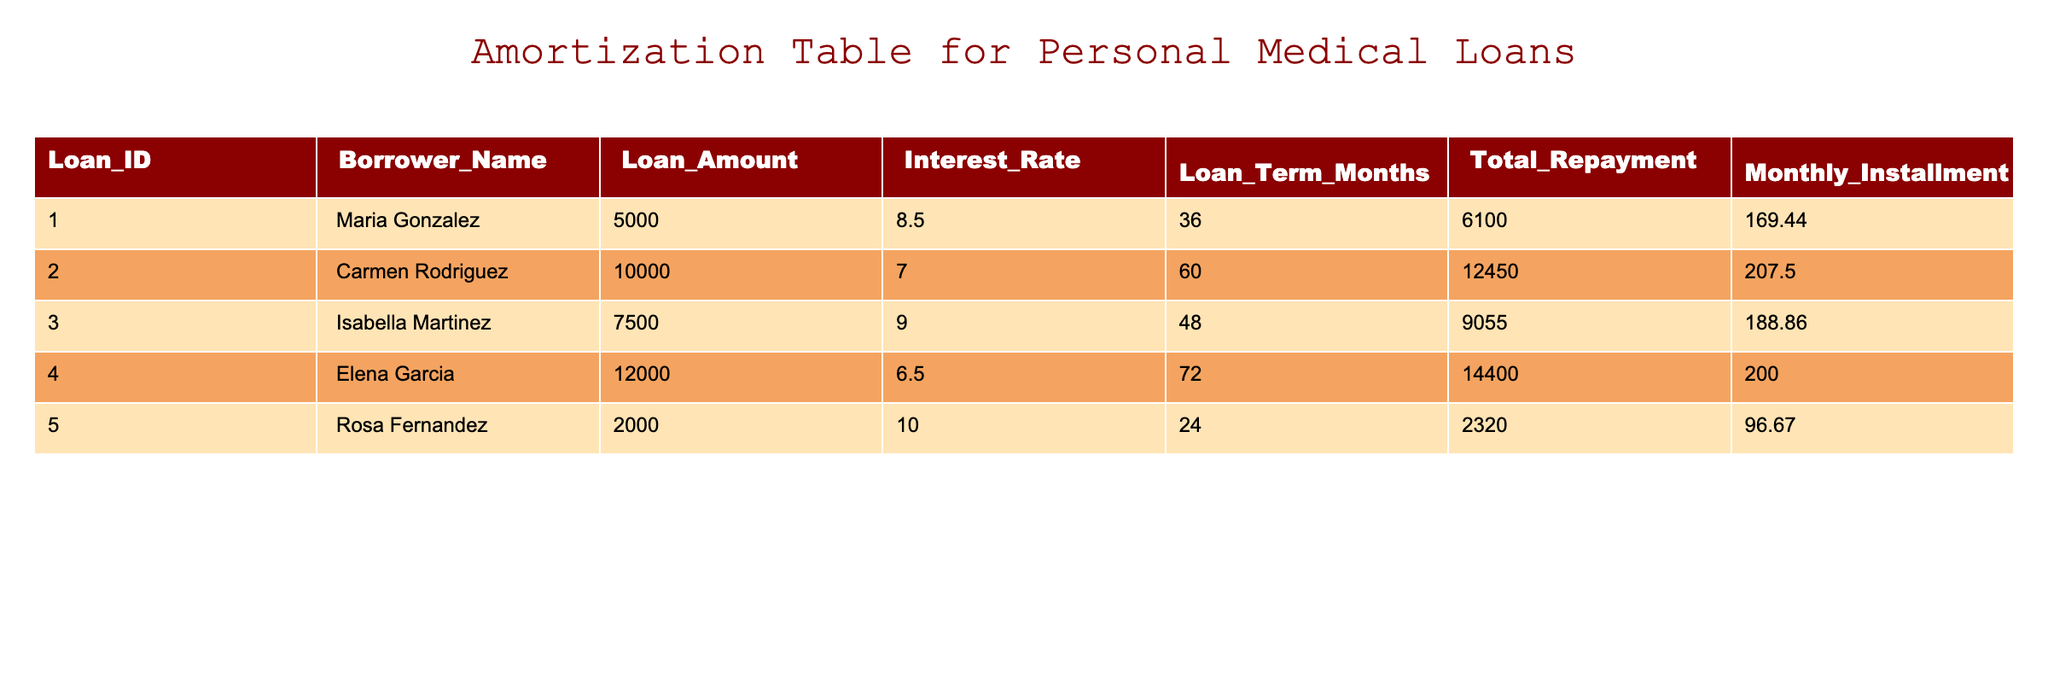What is the loan amount for Carmen Rodriguez? Look at the 'Loan_Amount' column in the table, find the corresponding row for Carmen Rodriguez, which shows the loan amount as 10000.
Answer: 10000 What is the monthly installment for Rosa Fernandez? In the table, under the 'Monthly_Installment' column, the value for Rosa Fernandez is listed as 96.67.
Answer: 96.67 Which borrower has the lowest interest rate? Compare the 'Interest_Rate' column values for all borrowers; Elena Garcia has the lowest rate at 6.5.
Answer: Elena Garcia What is the total repayment amount for all loans combined? Sum the 'Total_Repayment' amounts for all borrowers: 6100 + 12450 + 9055 + 14400 + 2320 = 40325.
Answer: 40325 Is the monthly installment for Isabella Martinez greater than 200? Check the value in the 'Monthly_Installment' for Isabella Martinez, which is 188.86; since 188.86 is less than 200, the answer is no.
Answer: No What is the difference between the loan amount of Maria Gonzalez and that of Rosa Fernandez? Maria Gonzalez's loan amount is 5000, and Rosa Fernandez's loan amount is 2000. The difference is 5000 - 2000 = 3000.
Answer: 3000 Which borrower will pay more total repayment, and by how much, between Isabella Martinez and Elena Garcia? Total repayment for Isabella Martinez is 9055, and for Elena Garcia, it is 14400. The difference is 14400 - 9055 = 5345, indicating Elena Garcia pays more by 5345.
Answer: Elena Garcia, 5345 If the average interest rate of the loans is calculated, what would it be? Sum all interest rates: 8.5 + 7.0 + 9.0 + 6.5 + 10.0 = 41.0, then divide by the total number of borrowers (5), giving an average of 41.0 / 5 = 8.2.
Answer: 8.2 Are there any loans with a loan term of 60 months or more? Inspect the 'Loan_Term_Months' column and see that both Elena Garcia and Carmen Rodriguez have terms of 72 and 60 months respectively; therefore, the answer is yes.
Answer: Yes 